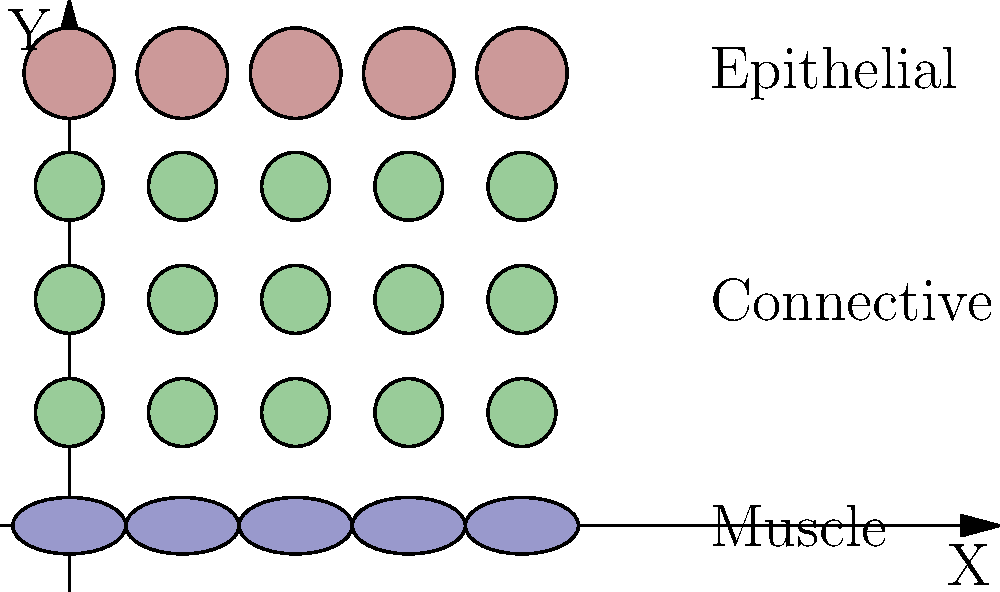In the tissue sample shown, what is the correct order of cell layers from top to bottom, and how many distinct layers are present? To answer this question, we need to analyze the spatial arrangement of cells in the tissue sample:

1. Identify the cell types:
   - Top layer (pink circles): Epithelial cells
   - Middle layers (green circles): Connective tissue cells
   - Bottom layer (blue ellipses): Muscle cells

2. Count the distinct layers:
   - Epithelial layer: 1 layer
   - Connective tissue: 3 layers
   - Muscle layer: 1 layer
   Total: 5 distinct layers

3. Determine the order from top to bottom:
   1. Epithelial
   2. Connective
   3. Muscle

Therefore, the correct order of cell layers from top to bottom is Epithelial, Connective, Muscle, and there are 5 distinct layers in total.
Answer: Epithelial, Connective, Muscle; 5 layers 